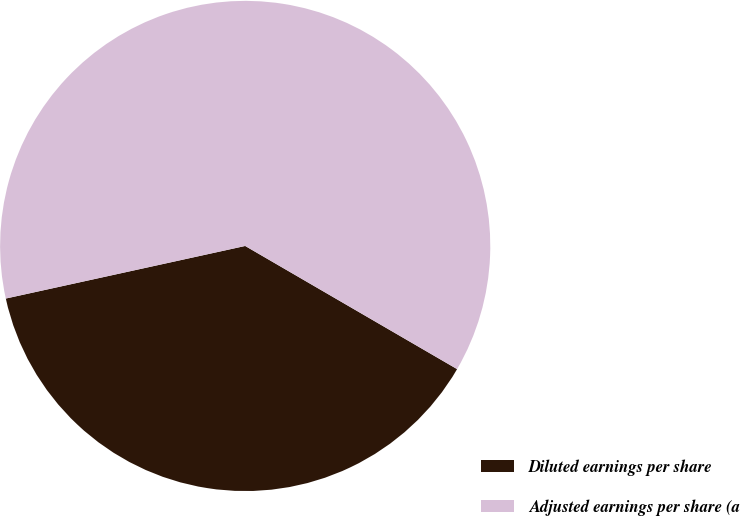Convert chart. <chart><loc_0><loc_0><loc_500><loc_500><pie_chart><fcel>Diluted earnings per share<fcel>Adjusted earnings per share (a<nl><fcel>38.18%<fcel>61.82%<nl></chart> 